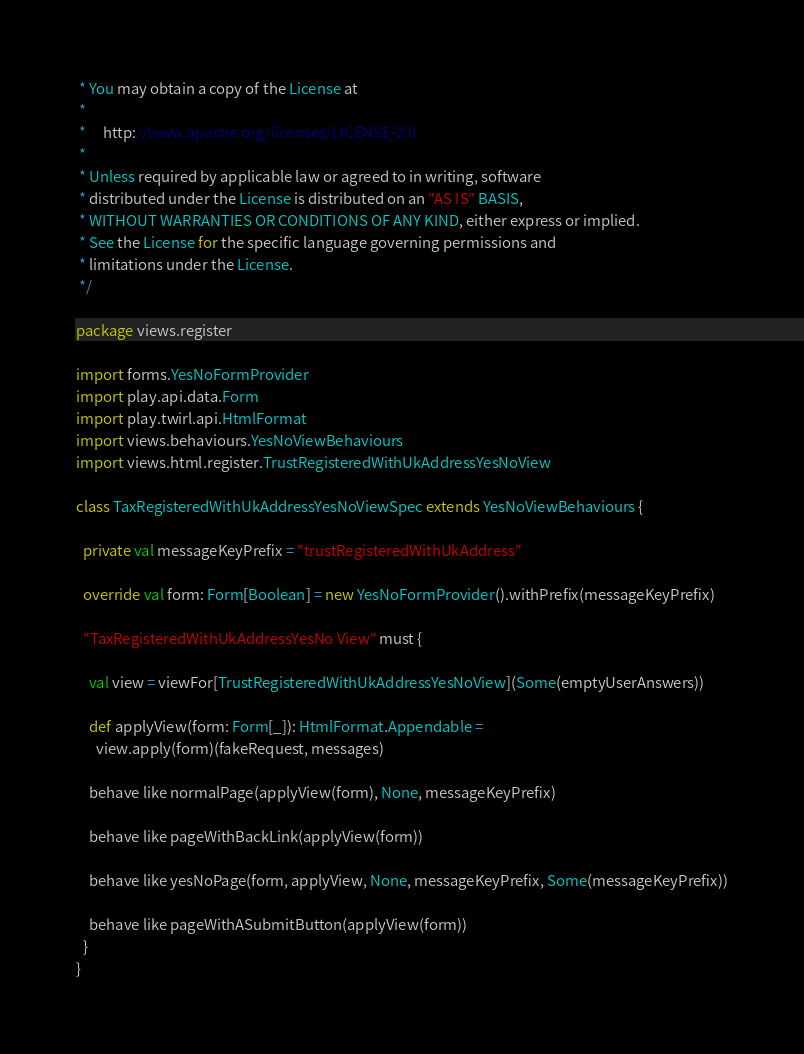Convert code to text. <code><loc_0><loc_0><loc_500><loc_500><_Scala_> * You may obtain a copy of the License at
 *
 *     http://www.apache.org/licenses/LICENSE-2.0
 *
 * Unless required by applicable law or agreed to in writing, software
 * distributed under the License is distributed on an "AS IS" BASIS,
 * WITHOUT WARRANTIES OR CONDITIONS OF ANY KIND, either express or implied.
 * See the License for the specific language governing permissions and
 * limitations under the License.
 */

package views.register

import forms.YesNoFormProvider
import play.api.data.Form
import play.twirl.api.HtmlFormat
import views.behaviours.YesNoViewBehaviours
import views.html.register.TrustRegisteredWithUkAddressYesNoView

class TaxRegisteredWithUkAddressYesNoViewSpec extends YesNoViewBehaviours {

  private val messageKeyPrefix = "trustRegisteredWithUkAddress"

  override val form: Form[Boolean] = new YesNoFormProvider().withPrefix(messageKeyPrefix)

  "TaxRegisteredWithUkAddressYesNo View" must {

    val view = viewFor[TrustRegisteredWithUkAddressYesNoView](Some(emptyUserAnswers))

    def applyView(form: Form[_]): HtmlFormat.Appendable =
      view.apply(form)(fakeRequest, messages)

    behave like normalPage(applyView(form), None, messageKeyPrefix)

    behave like pageWithBackLink(applyView(form))

    behave like yesNoPage(form, applyView, None, messageKeyPrefix, Some(messageKeyPrefix))

    behave like pageWithASubmitButton(applyView(form))
  }
}
</code> 